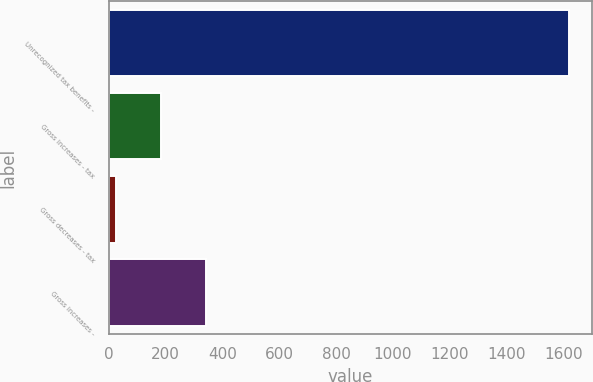<chart> <loc_0><loc_0><loc_500><loc_500><bar_chart><fcel>Unrecognized tax benefits -<fcel>Gross increases - tax<fcel>Gross decreases - tax<fcel>Gross increases -<nl><fcel>1617<fcel>184.2<fcel>25<fcel>343.4<nl></chart> 